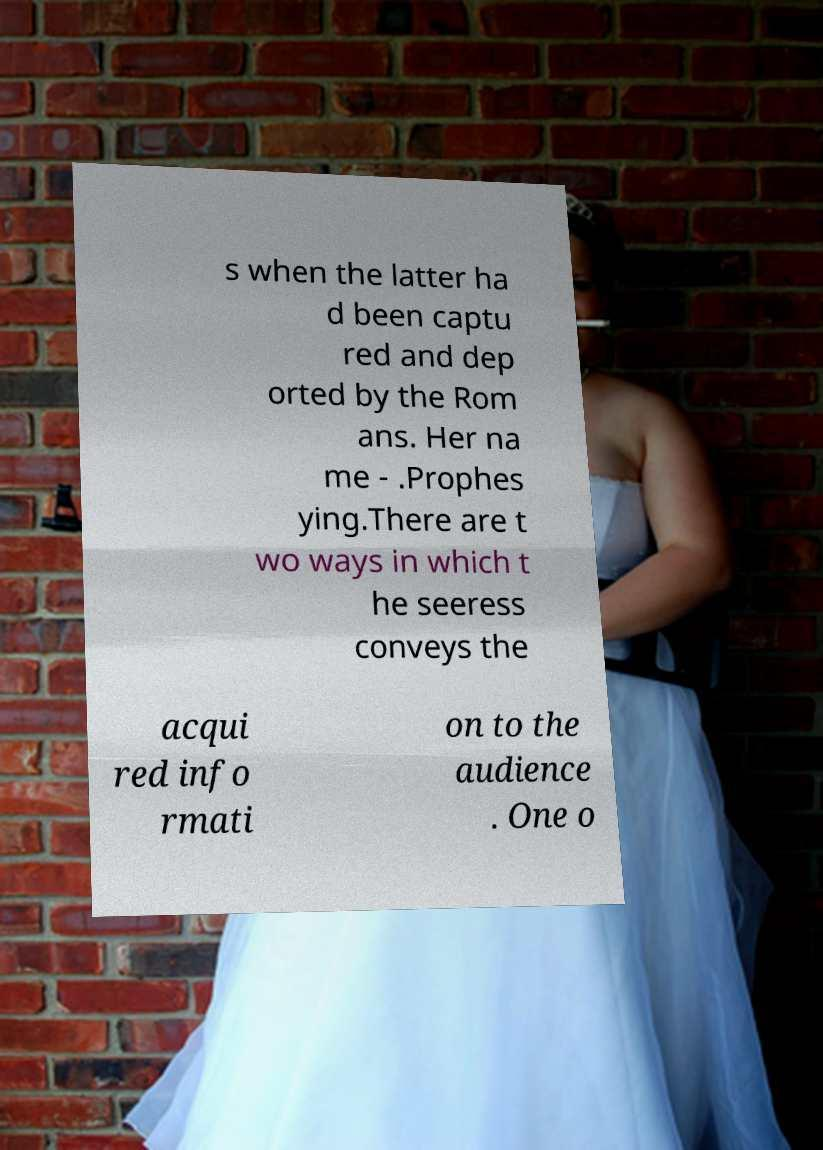I need the written content from this picture converted into text. Can you do that? s when the latter ha d been captu red and dep orted by the Rom ans. Her na me - .Prophes ying.There are t wo ways in which t he seeress conveys the acqui red info rmati on to the audience . One o 